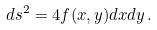Convert formula to latex. <formula><loc_0><loc_0><loc_500><loc_500>d s ^ { 2 } = 4 f ( x , y ) d x d y \, .</formula> 